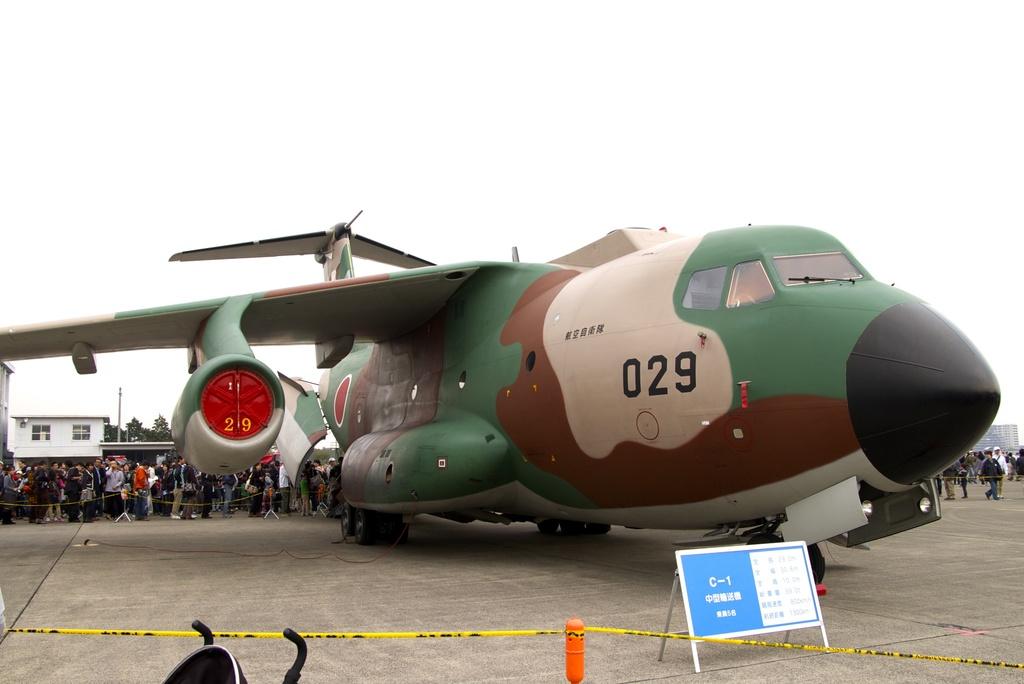What is the id number of the plane?
Your answer should be compact. 029. What runway is the plan on?
Make the answer very short. C-1. 